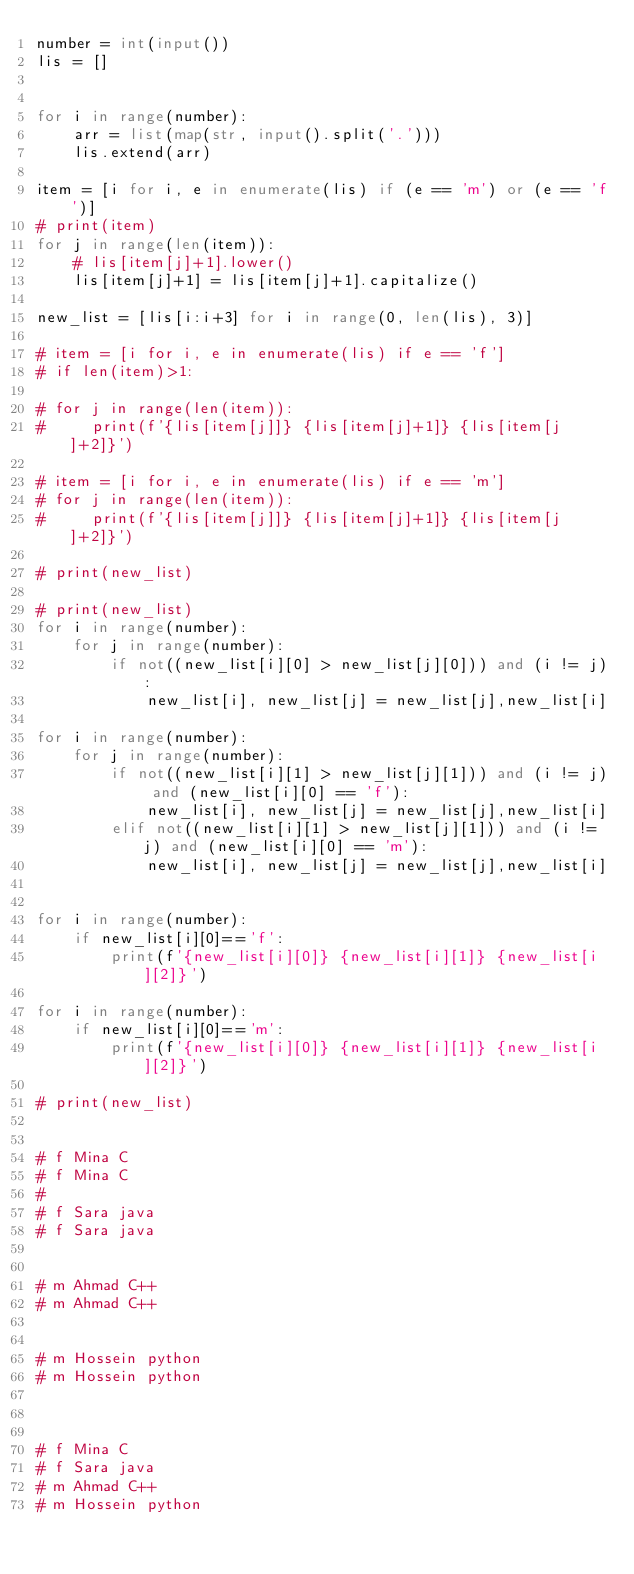Convert code to text. <code><loc_0><loc_0><loc_500><loc_500><_Python_>number = int(input())
lis = []


for i in range(number):
    arr = list(map(str, input().split('.')))
    lis.extend(arr)

item = [i for i, e in enumerate(lis) if (e == 'm') or (e == 'f')]
# print(item)
for j in range(len(item)):
    # lis[item[j]+1].lower()
    lis[item[j]+1] = lis[item[j]+1].capitalize()

new_list = [lis[i:i+3] for i in range(0, len(lis), 3)]

# item = [i for i, e in enumerate(lis) if e == 'f']
# if len(item)>1:
  
# for j in range(len(item)):
#     print(f'{lis[item[j]]} {lis[item[j]+1]} {lis[item[j]+2]}')

# item = [i for i, e in enumerate(lis) if e == 'm']
# for j in range(len(item)):
#     print(f'{lis[item[j]]} {lis[item[j]+1]} {lis[item[j]+2]}')

# print(new_list)

# print(new_list)
for i in range(number):
    for j in range(number):
        if not((new_list[i][0] > new_list[j][0])) and (i != j):
            new_list[i], new_list[j] = new_list[j],new_list[i]

for i in range(number):
    for j in range(number):
        if not((new_list[i][1] > new_list[j][1])) and (i != j) and (new_list[i][0] == 'f'):
            new_list[i], new_list[j] = new_list[j],new_list[i]
        elif not((new_list[i][1] > new_list[j][1])) and (i != j) and (new_list[i][0] == 'm'):
            new_list[i], new_list[j] = new_list[j],new_list[i]


for i in range(number):
    if new_list[i][0]=='f':
        print(f'{new_list[i][0]} {new_list[i][1]} {new_list[i][2]}')

for i in range(number):
    if new_list[i][0]=='m':
        print(f'{new_list[i][0]} {new_list[i][1]} {new_list[i][2]}')

# print(new_list)


# f Mina C
# f Mina C
#    
# f Sara java
# f Sara java


# m Ahmad C++
# m Ahmad C++


# m Hossein python
# m Hossein python



# f Mina C
# f Sara java
# m Ahmad C++
# m Hossein python</code> 